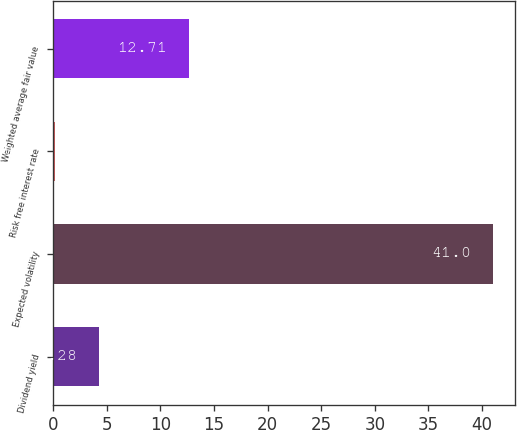Convert chart. <chart><loc_0><loc_0><loc_500><loc_500><bar_chart><fcel>Dividend yield<fcel>Expected volatility<fcel>Risk free interest rate<fcel>Weighted average fair value<nl><fcel>4.28<fcel>41<fcel>0.2<fcel>12.71<nl></chart> 